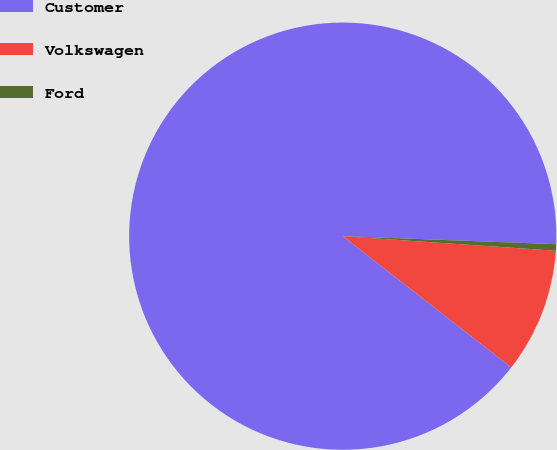Convert chart to OTSL. <chart><loc_0><loc_0><loc_500><loc_500><pie_chart><fcel>Customer<fcel>Volkswagen<fcel>Ford<nl><fcel>90.06%<fcel>9.45%<fcel>0.49%<nl></chart> 